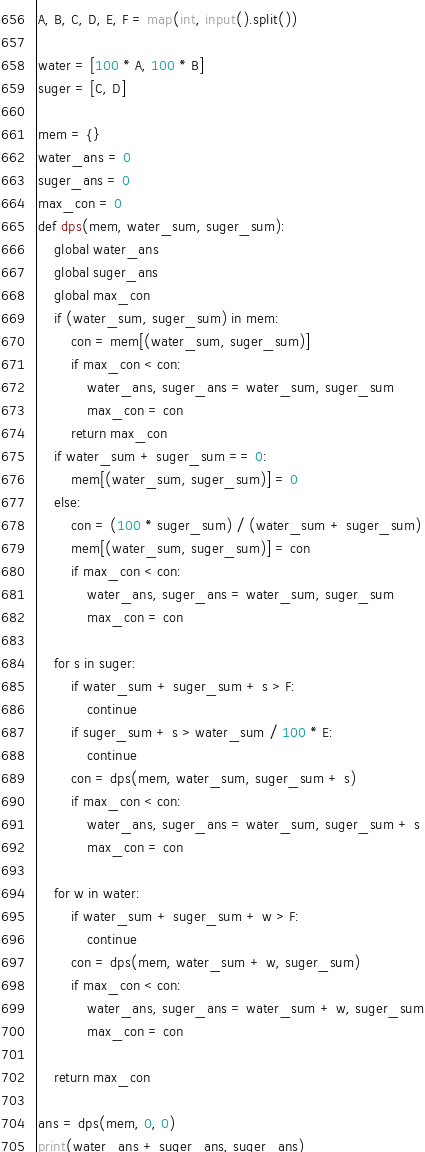Convert code to text. <code><loc_0><loc_0><loc_500><loc_500><_Python_>A, B, C, D, E, F = map(int, input().split())

water = [100 * A, 100 * B]
suger = [C, D]

mem = {}
water_ans = 0
suger_ans = 0
max_con = 0
def dps(mem, water_sum, suger_sum):
    global water_ans
    global suger_ans
    global max_con
    if (water_sum, suger_sum) in mem:
        con = mem[(water_sum, suger_sum)]
        if max_con < con:
            water_ans, suger_ans = water_sum, suger_sum
            max_con = con
        return max_con
    if water_sum + suger_sum == 0:
        mem[(water_sum, suger_sum)] = 0
    else:
        con = (100 * suger_sum) / (water_sum + suger_sum)
        mem[(water_sum, suger_sum)] = con
        if max_con < con:
            water_ans, suger_ans = water_sum, suger_sum
            max_con = con

    for s in suger:
        if water_sum + suger_sum + s > F:
            continue
        if suger_sum + s > water_sum / 100 * E:
            continue
        con = dps(mem, water_sum, suger_sum + s)
        if max_con < con:
            water_ans, suger_ans = water_sum, suger_sum + s
            max_con = con

    for w in water:
        if water_sum + suger_sum + w > F:
            continue
        con = dps(mem, water_sum + w, suger_sum)
        if max_con < con:
            water_ans, suger_ans = water_sum + w, suger_sum
            max_con = con

    return max_con 

ans = dps(mem, 0, 0)
print(water_ans + suger_ans, suger_ans)</code> 